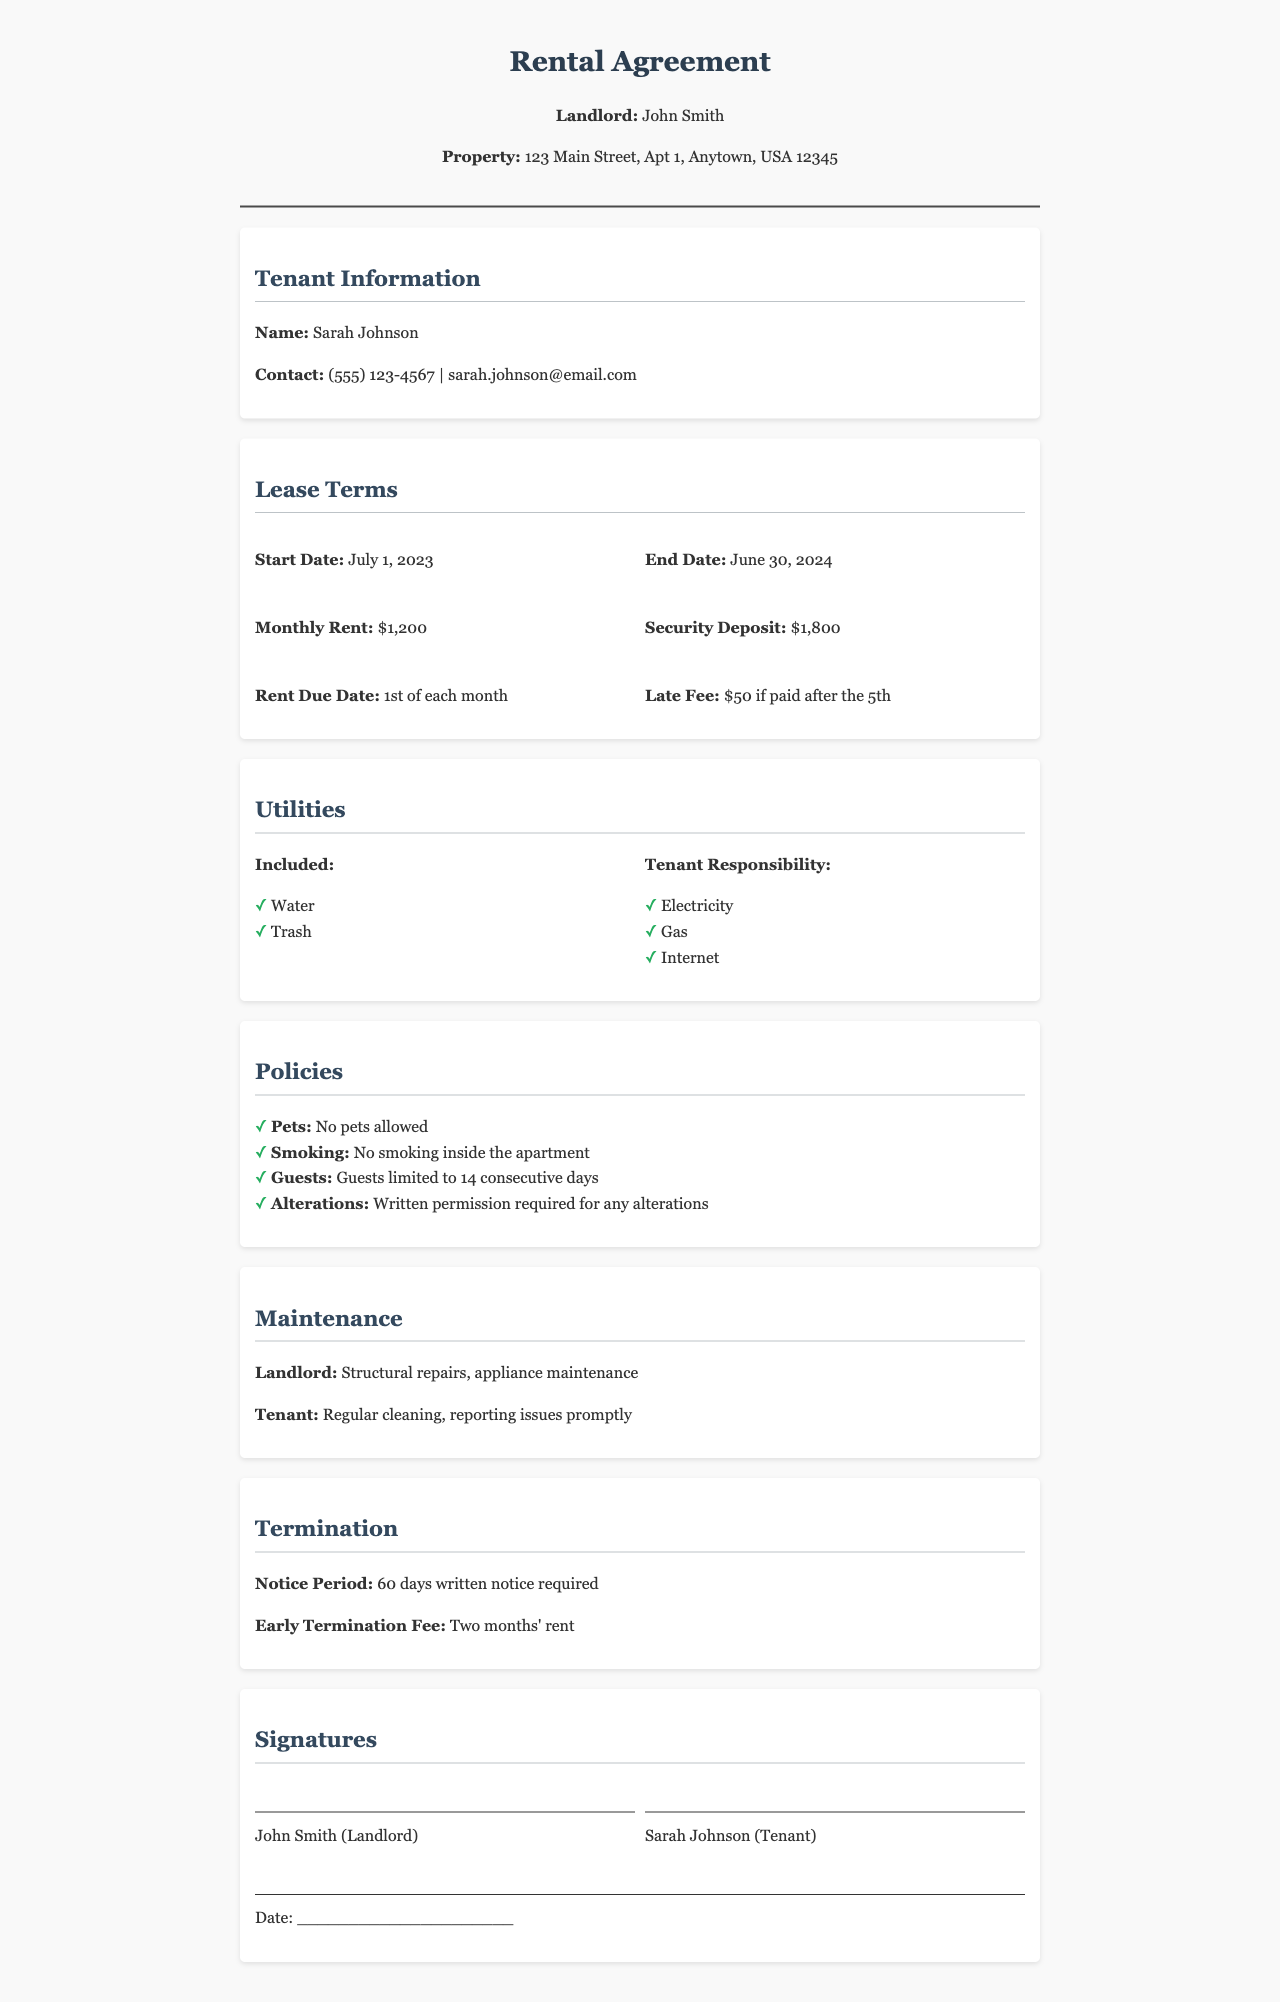What is the Landlord's name? The Landlord's name is listed at the top of the document.
Answer: John Smith What is the monthly rent? The monthly rent is specified in the Lease Terms section.
Answer: $1,200 When does the lease start? The start date is included in the Lease Terms section of the document.
Answer: July 1, 2023 What is the security deposit amount? The security deposit is detailed in the Lease Terms section.
Answer: $1,800 How long is the notice period for termination? The notice period is stated in the Termination section of the document.
Answer: 60 days What utilities are included? The included utilities are listed under the Utilities section.
Answer: Water, Trash Are pets allowed? The policy regarding pets is found in the Policies section.
Answer: No pets allowed What is the late fee amount? The late fee amount is mentioned in the Lease Terms section.
Answer: $50 What responsibilities does the landlord have? The landlord's responsibilities are outlined in the Maintenance section.
Answer: Structural repairs, appliance maintenance What is the early termination fee? The early termination fee is specified in the Termination section of the document.
Answer: Two months' rent 